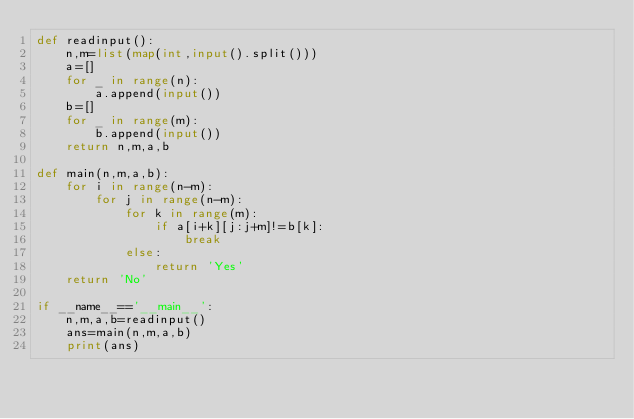Convert code to text. <code><loc_0><loc_0><loc_500><loc_500><_Python_>def readinput():
    n,m=list(map(int,input().split()))
    a=[]
    for _ in range(n):
        a.append(input())
    b=[]
    for _ in range(m):
        b.append(input())
    return n,m,a,b

def main(n,m,a,b):
    for i in range(n-m):
        for j in range(n-m):
            for k in range(m):
                if a[i+k][j:j+m]!=b[k]:
                    break
            else:
                return 'Yes'
    return 'No'

if __name__=='__main__':
    n,m,a,b=readinput()
    ans=main(n,m,a,b)
    print(ans)
</code> 